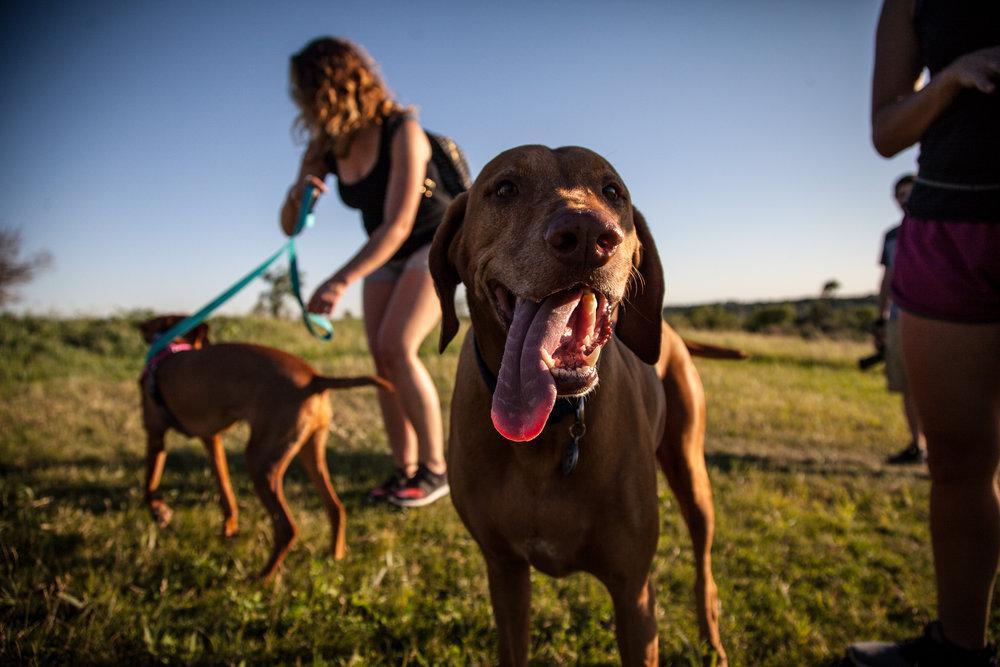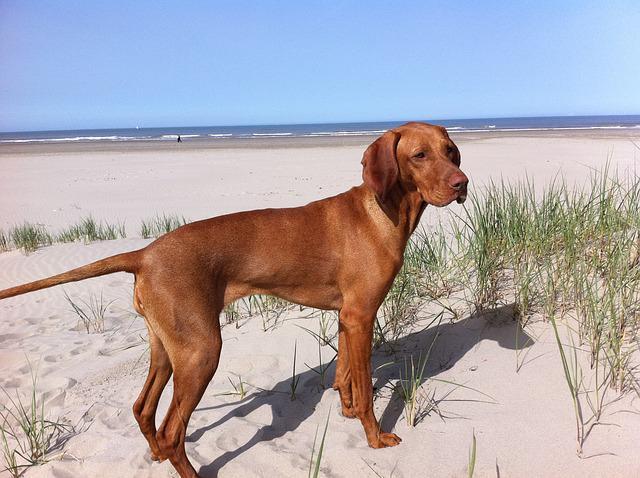The first image is the image on the left, the second image is the image on the right. For the images displayed, is the sentence "There are three dogs in the image pair." factually correct? Answer yes or no. Yes. The first image is the image on the left, the second image is the image on the right. For the images shown, is this caption "The dog in the image on the right is standing on the sand." true? Answer yes or no. Yes. 